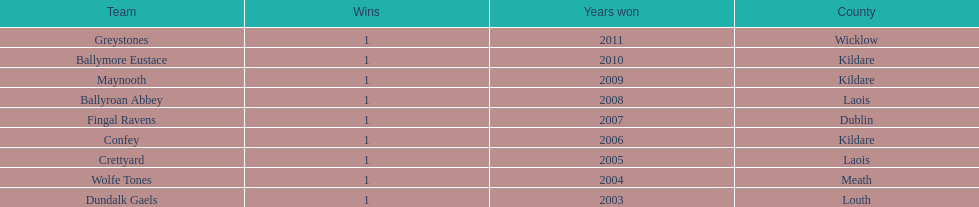What is the years won for each team 2011, 2010, 2009, 2008, 2007, 2006, 2005, 2004, 2003. 